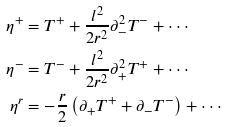<formula> <loc_0><loc_0><loc_500><loc_500>\eta ^ { + } & = T ^ { + } + \frac { l ^ { 2 } } { 2 r ^ { 2 } } \partial _ { - } ^ { 2 } T ^ { - } + \cdot \cdot \cdot \\ \eta ^ { - } & = T ^ { - } + \frac { l ^ { 2 } } { 2 r ^ { 2 } } \partial _ { + } ^ { 2 } T ^ { + } + \cdot \cdot \cdot \\ \eta ^ { r } & = - \frac { r } { 2 } \left ( \partial _ { + } T ^ { + } + \partial _ { - } T ^ { - } \right ) + \cdot \cdot \cdot</formula> 